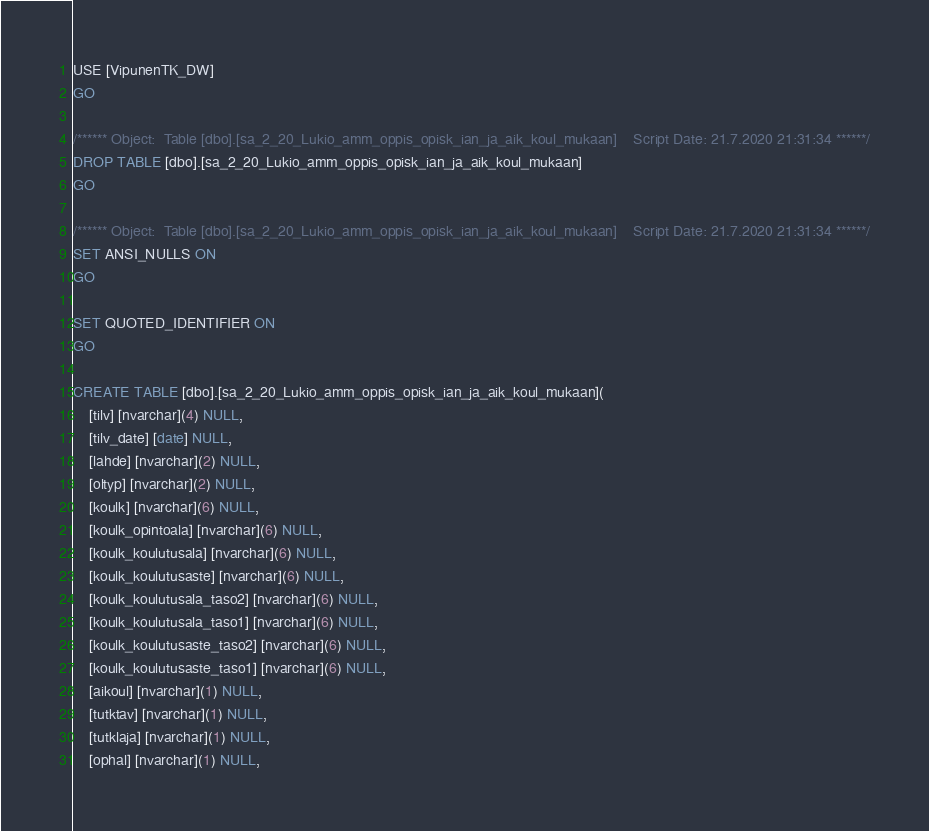<code> <loc_0><loc_0><loc_500><loc_500><_SQL_>USE [VipunenTK_DW]
GO

/****** Object:  Table [dbo].[sa_2_20_Lukio_amm_oppis_opisk_ian_ja_aik_koul_mukaan]    Script Date: 21.7.2020 21:31:34 ******/
DROP TABLE [dbo].[sa_2_20_Lukio_amm_oppis_opisk_ian_ja_aik_koul_mukaan]
GO

/****** Object:  Table [dbo].[sa_2_20_Lukio_amm_oppis_opisk_ian_ja_aik_koul_mukaan]    Script Date: 21.7.2020 21:31:34 ******/
SET ANSI_NULLS ON
GO

SET QUOTED_IDENTIFIER ON
GO

CREATE TABLE [dbo].[sa_2_20_Lukio_amm_oppis_opisk_ian_ja_aik_koul_mukaan](
	[tilv] [nvarchar](4) NULL,
	[tilv_date] [date] NULL,
	[lahde] [nvarchar](2) NULL,
	[oltyp] [nvarchar](2) NULL,
	[koulk] [nvarchar](6) NULL,
	[koulk_opintoala] [nvarchar](6) NULL,
	[koulk_koulutusala] [nvarchar](6) NULL,
	[koulk_koulutusaste] [nvarchar](6) NULL,
	[koulk_koulutusala_taso2] [nvarchar](6) NULL,
	[koulk_koulutusala_taso1] [nvarchar](6) NULL,
	[koulk_koulutusaste_taso2] [nvarchar](6) NULL,
	[koulk_koulutusaste_taso1] [nvarchar](6) NULL,
	[aikoul] [nvarchar](1) NULL,
	[tutktav] [nvarchar](1) NULL,
	[tutklaja] [nvarchar](1) NULL,
	[ophal] [nvarchar](1) NULL,</code> 